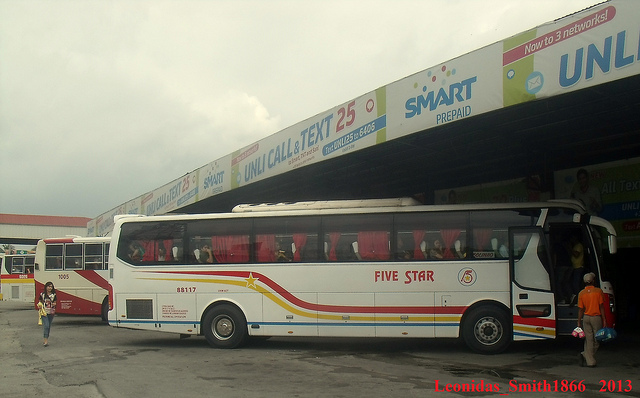<image>What city is this? It is unknown what city this is. It could be Tucson, Tijuana, London, Mexico, Chicago, Boston, or New York. What city is this? I don't know what city this is. It can be Tucson, Tijuana, London, Mexico, Chicago, Boston, or New York. 